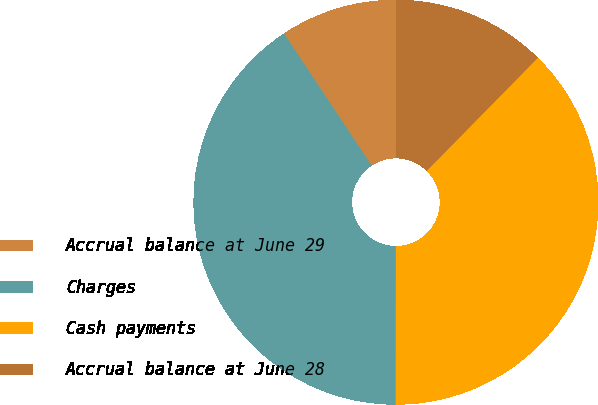Convert chart. <chart><loc_0><loc_0><loc_500><loc_500><pie_chart><fcel>Accrual balance at June 29<fcel>Charges<fcel>Cash payments<fcel>Accrual balance at June 28<nl><fcel>9.34%<fcel>40.66%<fcel>37.65%<fcel>12.35%<nl></chart> 